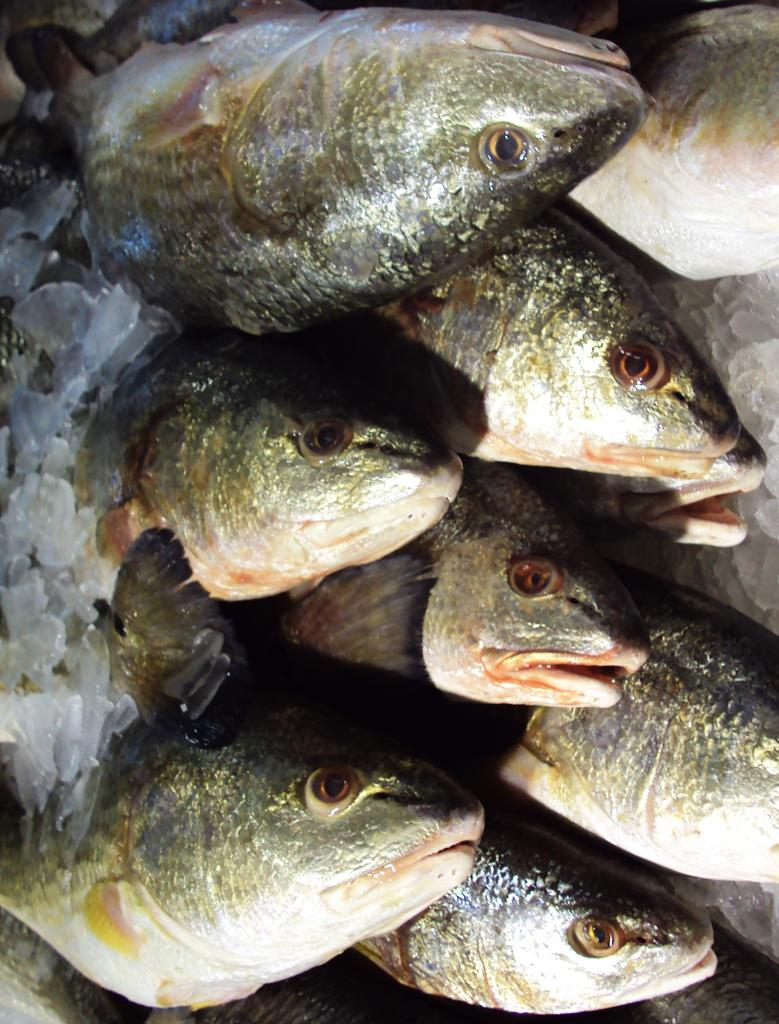What is the main subject of the image? The main subject of the image is a fish. What can be observed about the background of the image? The background of the image appears to be ice-like. What type of steel is visible in the image? There is no steel present in the image; it features a fish in an ice-like background. What type of tank is the fish swimming in? The image does not show the fish swimming in a tank; it only shows the fish and the ice-like background. 